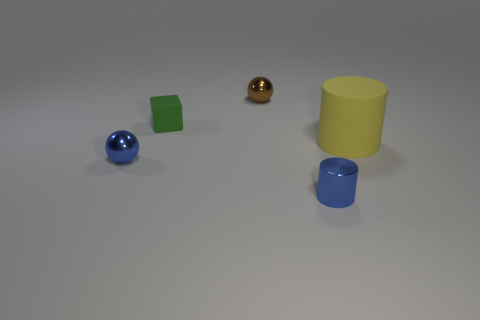Add 4 gray metallic blocks. How many objects exist? 9 Subtract all yellow cylinders. How many cylinders are left? 1 Subtract all small blue cylinders. Subtract all large brown cylinders. How many objects are left? 4 Add 3 yellow cylinders. How many yellow cylinders are left? 4 Add 3 brown shiny objects. How many brown shiny objects exist? 4 Subtract 0 yellow balls. How many objects are left? 5 Subtract all balls. How many objects are left? 3 